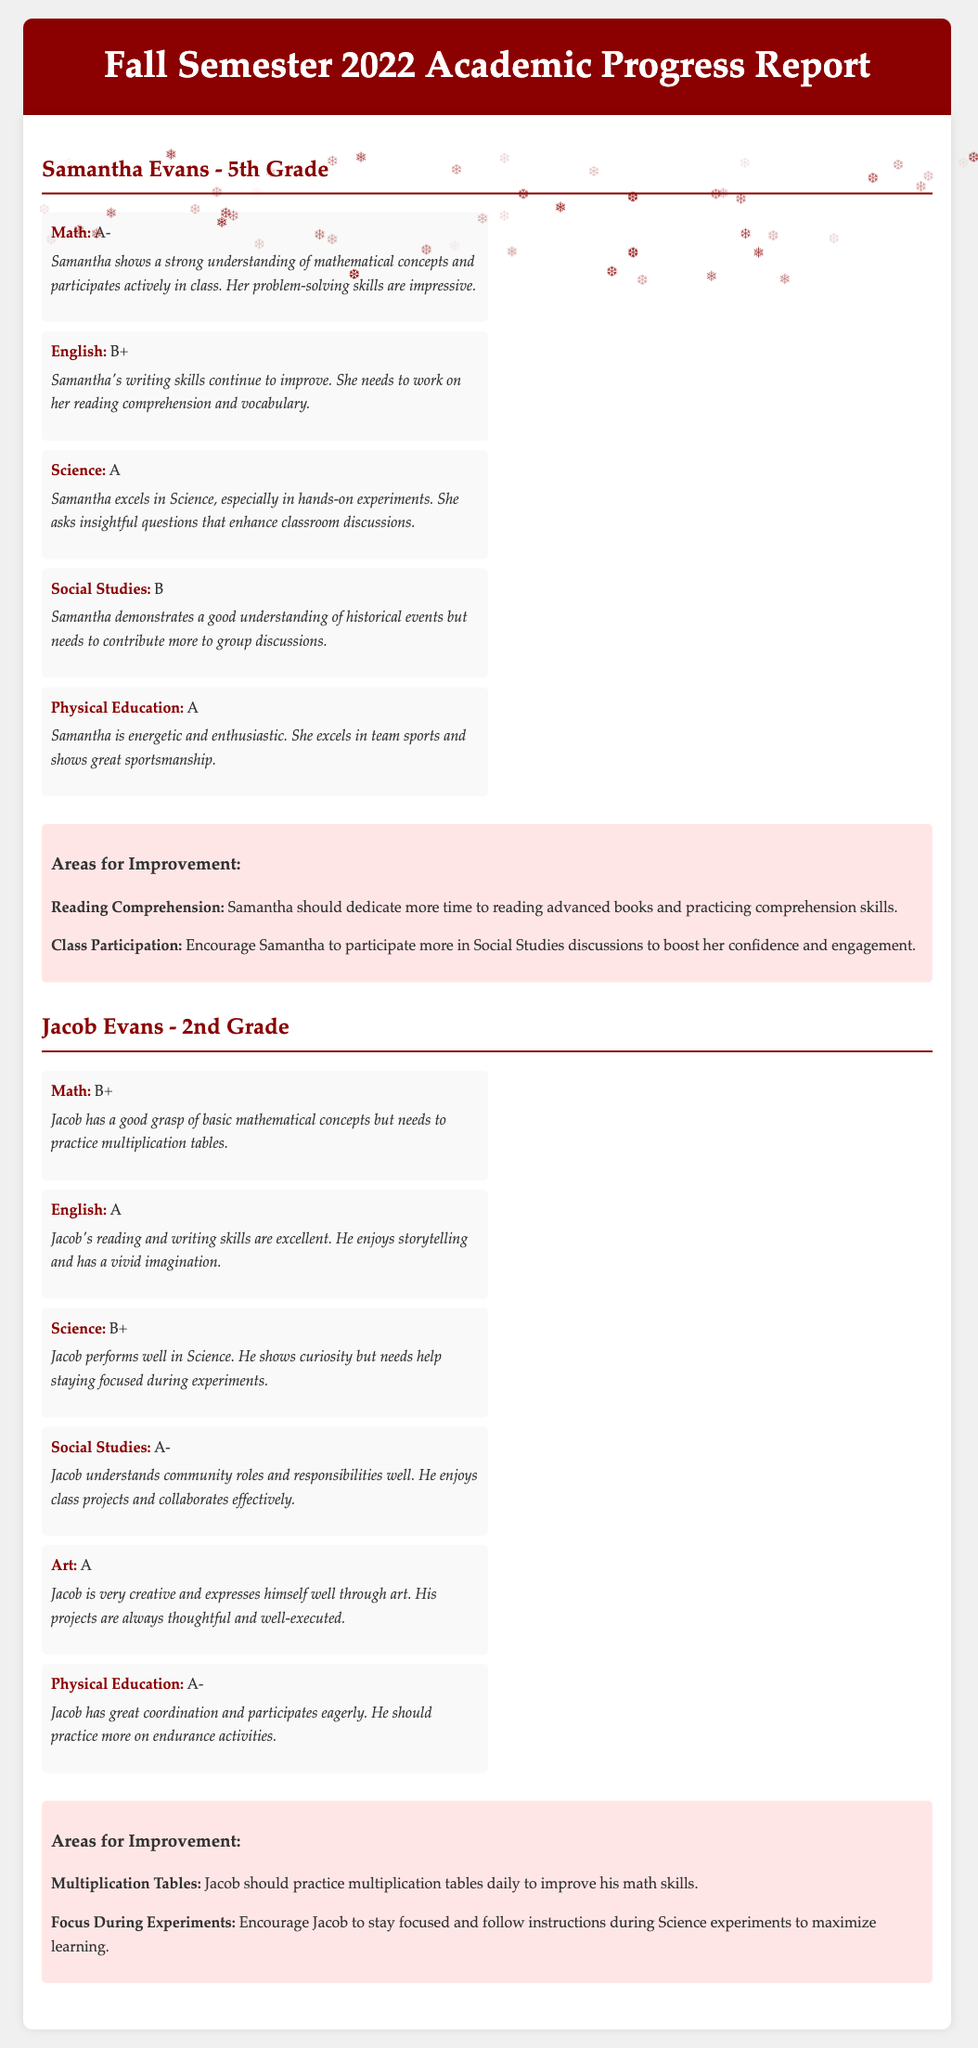What is Samantha's grade in Math? Samantha's grade in Math is listed in the document.
Answer: A- What comment did the teacher provide for Jacob's English performance? The comment for Jacob's English performance is included in the document under the English grade.
Answer: Jacob's reading and writing skills are excellent What area does Samantha need to improve in? The document lists specific areas for improvement for both students.
Answer: Reading Comprehension What subject did Jacob excel in besides English? Jacob received high grades in multiple subjects, which are detailed in the document.
Answer: Art What grade did Jacob receive in Science? The document provides Jacob's grades for different subjects, including Science.
Answer: B+ What comment was made regarding Samantha's participation in Social Studies? The comment is located next to Samantha's grade for Social Studies in the document.
Answer: Needs to contribute more to group discussions How many subjects did Jacob receive an A in? The document outlines Jacob's grades for multiple subjects.
Answer: 3 